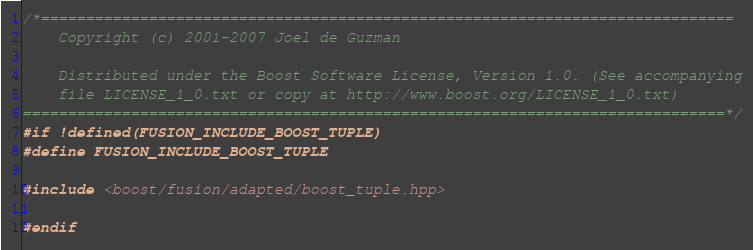Convert code to text. <code><loc_0><loc_0><loc_500><loc_500><_C++_>/*=============================================================================
    Copyright (c) 2001-2007 Joel de Guzman

    Distributed under the Boost Software License, Version 1.0. (See accompanying
    file LICENSE_1_0.txt or copy at http://www.boost.org/LICENSE_1_0.txt)
==============================================================================*/
#if !defined(FUSION_INCLUDE_BOOST_TUPLE)
#define FUSION_INCLUDE_BOOST_TUPLE

#include <boost/fusion/adapted/boost_tuple.hpp>

#endif
</code> 